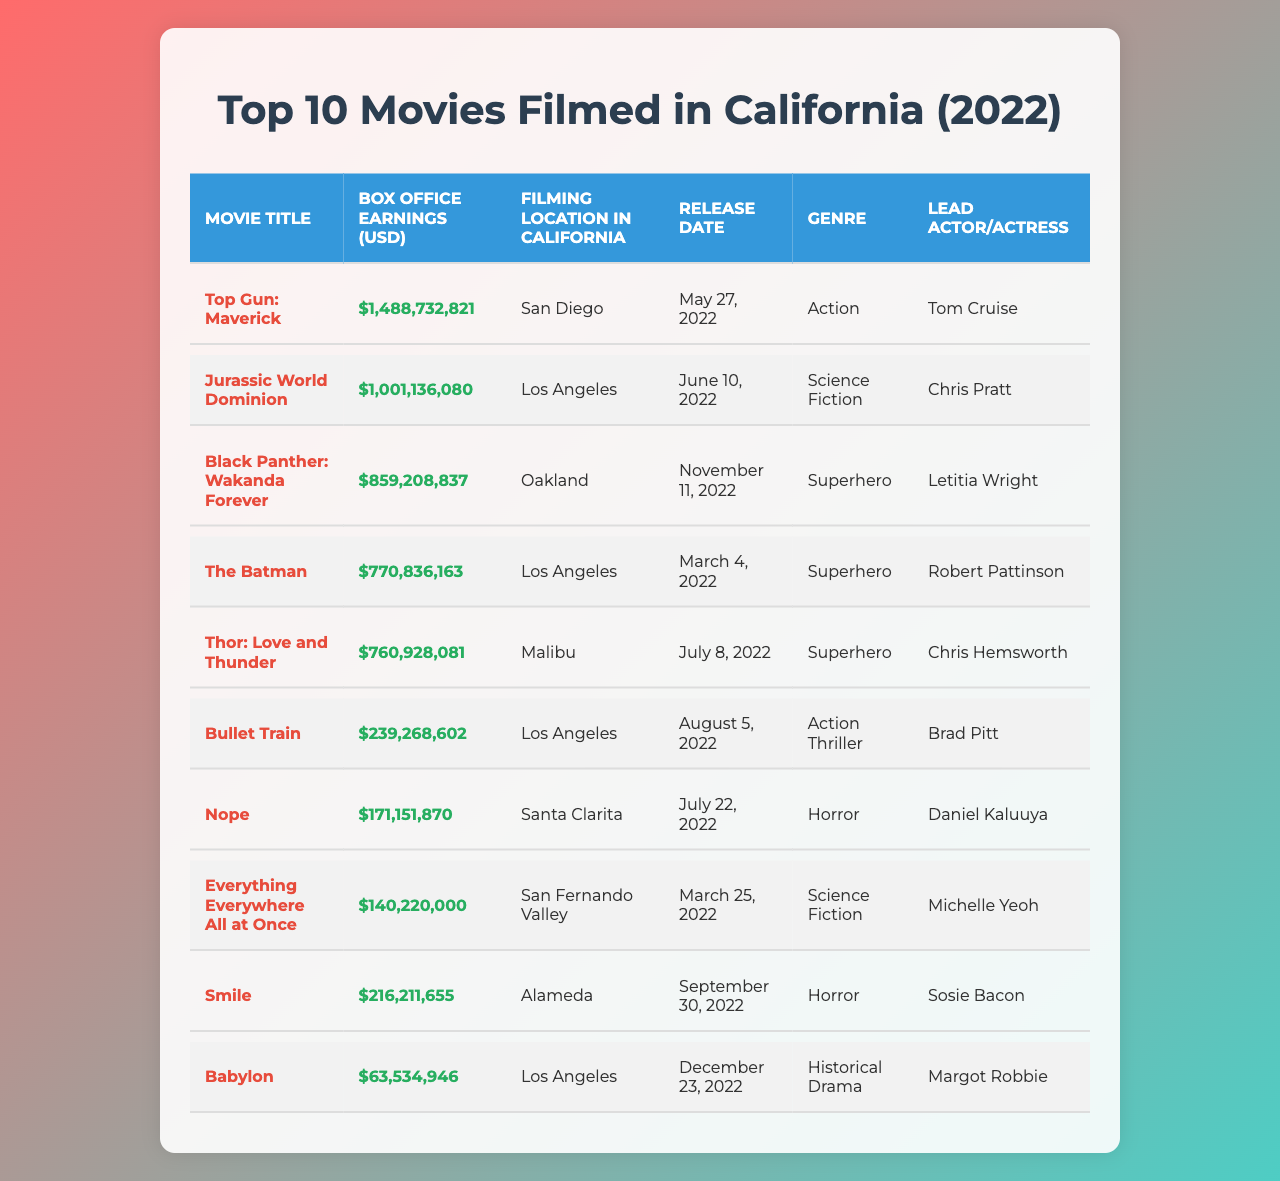What is the highest box office earning among the movies filmed in California in 2022? The table shows the box office earnings of movies filmed in California. The highest earning is listed as "Top Gun: Maverick" with earnings of $1,488,732,821.
Answer: $1,488,732,821 Which movie was filmed in Oakland? The table indicates that "Black Panther: Wakanda Forever" is the movie that was filmed in Oakland.
Answer: Black Panther: Wakanda Forever What is the release date of "Jurassic World Dominion"? According to the table, "Jurassic World Dominion" was released on June 10, 2022.
Answer: June 10, 2022 How many movies in the table fall under the superhero genre? The table lists four movies under the superhero genre: "Black Panther: Wakanda Forever," "The Batman," and "Thor: Love and Thunder." Thus, the count is 3.
Answer: 3 What are the box office earnings of "Smile"? The table shows that "Smile" has box office earnings of $216,211,655.
Answer: $216,211,655 What is the average box office earnings of the films listed in the table? To find the average, we sum all the earnings: $1,488,732,821 + $1,001,136,080 + $859,208,837 + $770,836,163 + $760,928,081 + $239,268,602 + $171,151,870 + $140,220,000 + $216,211,655 + $63,534,946 = $5,651,061,176. Then divide by the number of movies, which is 10, giving an average of $565,106,117.6.
Answer: $565,106,117.6 Which filming location had the lowest box office earnings in the table? The table lists "Los Angeles" with "Babylon" showing the lowest box office earnings of $63,534,946.
Answer: Los Angeles Is "Everything Everywhere All at Once" also categorized as a superhero film? The table classifies "Everything Everywhere All at Once" under the science fiction genre, not as a superhero film.
Answer: No What was the lead actor or actress of "Bullet Train"? Referring to the table, the lead actor of "Bullet Train" is Brad Pitt.
Answer: Brad Pitt How much more did "Top Gun: Maverick" earn compared to "Jurassic World Dominion"? The earnings for "Top Gun: Maverick" are $1,488,732,821 and for "Jurassic World Dominion" are $1,001,136,080. The difference is $1,488,732,821 - $1,001,136,080 = $487,596,741.
Answer: $487,596,741 Which movie's earnings I can say were in the horror genre? According to the table, the movies "Nope" and "Smile" are classified under the horror genre.
Answer: Nope and Smile 